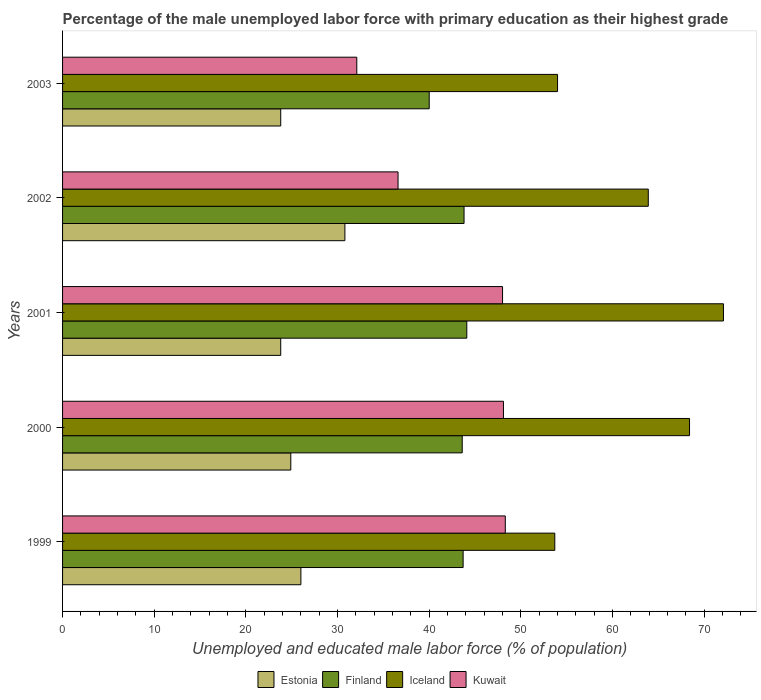How many groups of bars are there?
Ensure brevity in your answer.  5. Are the number of bars per tick equal to the number of legend labels?
Your response must be concise. Yes. Are the number of bars on each tick of the Y-axis equal?
Offer a terse response. Yes. How many bars are there on the 5th tick from the top?
Keep it short and to the point. 4. How many bars are there on the 4th tick from the bottom?
Your answer should be very brief. 4. In how many cases, is the number of bars for a given year not equal to the number of legend labels?
Offer a very short reply. 0. What is the percentage of the unemployed male labor force with primary education in Kuwait in 2000?
Your response must be concise. 48.1. Across all years, what is the maximum percentage of the unemployed male labor force with primary education in Kuwait?
Provide a short and direct response. 48.3. Across all years, what is the minimum percentage of the unemployed male labor force with primary education in Estonia?
Your answer should be very brief. 23.8. In which year was the percentage of the unemployed male labor force with primary education in Estonia maximum?
Give a very brief answer. 2002. What is the total percentage of the unemployed male labor force with primary education in Iceland in the graph?
Your answer should be very brief. 312.1. What is the difference between the percentage of the unemployed male labor force with primary education in Iceland in 1999 and that in 2002?
Provide a succinct answer. -10.2. What is the difference between the percentage of the unemployed male labor force with primary education in Iceland in 2000 and the percentage of the unemployed male labor force with primary education in Estonia in 1999?
Give a very brief answer. 42.4. What is the average percentage of the unemployed male labor force with primary education in Kuwait per year?
Ensure brevity in your answer.  42.62. In the year 2001, what is the difference between the percentage of the unemployed male labor force with primary education in Iceland and percentage of the unemployed male labor force with primary education in Kuwait?
Keep it short and to the point. 24.1. What is the ratio of the percentage of the unemployed male labor force with primary education in Iceland in 1999 to that in 2001?
Ensure brevity in your answer.  0.74. Is the difference between the percentage of the unemployed male labor force with primary education in Iceland in 1999 and 2001 greater than the difference between the percentage of the unemployed male labor force with primary education in Kuwait in 1999 and 2001?
Provide a short and direct response. No. What is the difference between the highest and the second highest percentage of the unemployed male labor force with primary education in Iceland?
Your response must be concise. 3.7. What is the difference between the highest and the lowest percentage of the unemployed male labor force with primary education in Iceland?
Offer a very short reply. 18.4. In how many years, is the percentage of the unemployed male labor force with primary education in Kuwait greater than the average percentage of the unemployed male labor force with primary education in Kuwait taken over all years?
Make the answer very short. 3. Is it the case that in every year, the sum of the percentage of the unemployed male labor force with primary education in Finland and percentage of the unemployed male labor force with primary education in Kuwait is greater than the sum of percentage of the unemployed male labor force with primary education in Estonia and percentage of the unemployed male labor force with primary education in Iceland?
Your response must be concise. No. What does the 1st bar from the top in 2000 represents?
Make the answer very short. Kuwait. What does the 4th bar from the bottom in 1999 represents?
Keep it short and to the point. Kuwait. How many bars are there?
Give a very brief answer. 20. Are all the bars in the graph horizontal?
Make the answer very short. Yes. What is the difference between two consecutive major ticks on the X-axis?
Offer a very short reply. 10. Are the values on the major ticks of X-axis written in scientific E-notation?
Your answer should be very brief. No. Does the graph contain grids?
Your answer should be compact. No. What is the title of the graph?
Ensure brevity in your answer.  Percentage of the male unemployed labor force with primary education as their highest grade. Does "Iraq" appear as one of the legend labels in the graph?
Offer a terse response. No. What is the label or title of the X-axis?
Your response must be concise. Unemployed and educated male labor force (% of population). What is the Unemployed and educated male labor force (% of population) of Estonia in 1999?
Offer a very short reply. 26. What is the Unemployed and educated male labor force (% of population) of Finland in 1999?
Provide a succinct answer. 43.7. What is the Unemployed and educated male labor force (% of population) in Iceland in 1999?
Your answer should be compact. 53.7. What is the Unemployed and educated male labor force (% of population) of Kuwait in 1999?
Provide a short and direct response. 48.3. What is the Unemployed and educated male labor force (% of population) of Estonia in 2000?
Make the answer very short. 24.9. What is the Unemployed and educated male labor force (% of population) in Finland in 2000?
Give a very brief answer. 43.6. What is the Unemployed and educated male labor force (% of population) of Iceland in 2000?
Your answer should be very brief. 68.4. What is the Unemployed and educated male labor force (% of population) of Kuwait in 2000?
Your answer should be compact. 48.1. What is the Unemployed and educated male labor force (% of population) of Estonia in 2001?
Provide a short and direct response. 23.8. What is the Unemployed and educated male labor force (% of population) in Finland in 2001?
Offer a very short reply. 44.1. What is the Unemployed and educated male labor force (% of population) in Iceland in 2001?
Offer a terse response. 72.1. What is the Unemployed and educated male labor force (% of population) in Estonia in 2002?
Your response must be concise. 30.8. What is the Unemployed and educated male labor force (% of population) of Finland in 2002?
Offer a very short reply. 43.8. What is the Unemployed and educated male labor force (% of population) in Iceland in 2002?
Your answer should be compact. 63.9. What is the Unemployed and educated male labor force (% of population) in Kuwait in 2002?
Your answer should be very brief. 36.6. What is the Unemployed and educated male labor force (% of population) in Estonia in 2003?
Offer a very short reply. 23.8. What is the Unemployed and educated male labor force (% of population) of Finland in 2003?
Your answer should be compact. 40. What is the Unemployed and educated male labor force (% of population) of Kuwait in 2003?
Your response must be concise. 32.1. Across all years, what is the maximum Unemployed and educated male labor force (% of population) in Estonia?
Your response must be concise. 30.8. Across all years, what is the maximum Unemployed and educated male labor force (% of population) of Finland?
Ensure brevity in your answer.  44.1. Across all years, what is the maximum Unemployed and educated male labor force (% of population) in Iceland?
Your answer should be very brief. 72.1. Across all years, what is the maximum Unemployed and educated male labor force (% of population) of Kuwait?
Offer a terse response. 48.3. Across all years, what is the minimum Unemployed and educated male labor force (% of population) of Estonia?
Ensure brevity in your answer.  23.8. Across all years, what is the minimum Unemployed and educated male labor force (% of population) of Finland?
Give a very brief answer. 40. Across all years, what is the minimum Unemployed and educated male labor force (% of population) of Iceland?
Your answer should be compact. 53.7. Across all years, what is the minimum Unemployed and educated male labor force (% of population) in Kuwait?
Ensure brevity in your answer.  32.1. What is the total Unemployed and educated male labor force (% of population) of Estonia in the graph?
Provide a succinct answer. 129.3. What is the total Unemployed and educated male labor force (% of population) in Finland in the graph?
Make the answer very short. 215.2. What is the total Unemployed and educated male labor force (% of population) in Iceland in the graph?
Your answer should be very brief. 312.1. What is the total Unemployed and educated male labor force (% of population) of Kuwait in the graph?
Provide a short and direct response. 213.1. What is the difference between the Unemployed and educated male labor force (% of population) in Estonia in 1999 and that in 2000?
Keep it short and to the point. 1.1. What is the difference between the Unemployed and educated male labor force (% of population) of Finland in 1999 and that in 2000?
Ensure brevity in your answer.  0.1. What is the difference between the Unemployed and educated male labor force (% of population) in Iceland in 1999 and that in 2000?
Give a very brief answer. -14.7. What is the difference between the Unemployed and educated male labor force (% of population) in Estonia in 1999 and that in 2001?
Make the answer very short. 2.2. What is the difference between the Unemployed and educated male labor force (% of population) of Finland in 1999 and that in 2001?
Make the answer very short. -0.4. What is the difference between the Unemployed and educated male labor force (% of population) in Iceland in 1999 and that in 2001?
Offer a very short reply. -18.4. What is the difference between the Unemployed and educated male labor force (% of population) of Estonia in 1999 and that in 2002?
Your answer should be very brief. -4.8. What is the difference between the Unemployed and educated male labor force (% of population) of Finland in 1999 and that in 2002?
Offer a very short reply. -0.1. What is the difference between the Unemployed and educated male labor force (% of population) in Iceland in 1999 and that in 2002?
Provide a short and direct response. -10.2. What is the difference between the Unemployed and educated male labor force (% of population) in Estonia in 1999 and that in 2003?
Provide a short and direct response. 2.2. What is the difference between the Unemployed and educated male labor force (% of population) in Estonia in 2000 and that in 2001?
Your answer should be compact. 1.1. What is the difference between the Unemployed and educated male labor force (% of population) in Iceland in 2000 and that in 2001?
Ensure brevity in your answer.  -3.7. What is the difference between the Unemployed and educated male labor force (% of population) of Kuwait in 2000 and that in 2001?
Keep it short and to the point. 0.1. What is the difference between the Unemployed and educated male labor force (% of population) of Finland in 2000 and that in 2002?
Provide a short and direct response. -0.2. What is the difference between the Unemployed and educated male labor force (% of population) in Iceland in 2000 and that in 2002?
Offer a terse response. 4.5. What is the difference between the Unemployed and educated male labor force (% of population) of Kuwait in 2000 and that in 2002?
Offer a very short reply. 11.5. What is the difference between the Unemployed and educated male labor force (% of population) of Estonia in 2000 and that in 2003?
Provide a succinct answer. 1.1. What is the difference between the Unemployed and educated male labor force (% of population) in Kuwait in 2000 and that in 2003?
Give a very brief answer. 16. What is the difference between the Unemployed and educated male labor force (% of population) in Finland in 2001 and that in 2002?
Keep it short and to the point. 0.3. What is the difference between the Unemployed and educated male labor force (% of population) of Kuwait in 2001 and that in 2002?
Keep it short and to the point. 11.4. What is the difference between the Unemployed and educated male labor force (% of population) of Estonia in 2001 and that in 2003?
Keep it short and to the point. 0. What is the difference between the Unemployed and educated male labor force (% of population) in Finland in 2001 and that in 2003?
Make the answer very short. 4.1. What is the difference between the Unemployed and educated male labor force (% of population) of Kuwait in 2002 and that in 2003?
Your answer should be compact. 4.5. What is the difference between the Unemployed and educated male labor force (% of population) of Estonia in 1999 and the Unemployed and educated male labor force (% of population) of Finland in 2000?
Your response must be concise. -17.6. What is the difference between the Unemployed and educated male labor force (% of population) of Estonia in 1999 and the Unemployed and educated male labor force (% of population) of Iceland in 2000?
Make the answer very short. -42.4. What is the difference between the Unemployed and educated male labor force (% of population) of Estonia in 1999 and the Unemployed and educated male labor force (% of population) of Kuwait in 2000?
Make the answer very short. -22.1. What is the difference between the Unemployed and educated male labor force (% of population) in Finland in 1999 and the Unemployed and educated male labor force (% of population) in Iceland in 2000?
Provide a succinct answer. -24.7. What is the difference between the Unemployed and educated male labor force (% of population) in Finland in 1999 and the Unemployed and educated male labor force (% of population) in Kuwait in 2000?
Give a very brief answer. -4.4. What is the difference between the Unemployed and educated male labor force (% of population) of Iceland in 1999 and the Unemployed and educated male labor force (% of population) of Kuwait in 2000?
Your answer should be very brief. 5.6. What is the difference between the Unemployed and educated male labor force (% of population) of Estonia in 1999 and the Unemployed and educated male labor force (% of population) of Finland in 2001?
Provide a succinct answer. -18.1. What is the difference between the Unemployed and educated male labor force (% of population) in Estonia in 1999 and the Unemployed and educated male labor force (% of population) in Iceland in 2001?
Keep it short and to the point. -46.1. What is the difference between the Unemployed and educated male labor force (% of population) of Finland in 1999 and the Unemployed and educated male labor force (% of population) of Iceland in 2001?
Your response must be concise. -28.4. What is the difference between the Unemployed and educated male labor force (% of population) of Estonia in 1999 and the Unemployed and educated male labor force (% of population) of Finland in 2002?
Your response must be concise. -17.8. What is the difference between the Unemployed and educated male labor force (% of population) of Estonia in 1999 and the Unemployed and educated male labor force (% of population) of Iceland in 2002?
Your response must be concise. -37.9. What is the difference between the Unemployed and educated male labor force (% of population) in Estonia in 1999 and the Unemployed and educated male labor force (% of population) in Kuwait in 2002?
Provide a short and direct response. -10.6. What is the difference between the Unemployed and educated male labor force (% of population) of Finland in 1999 and the Unemployed and educated male labor force (% of population) of Iceland in 2002?
Make the answer very short. -20.2. What is the difference between the Unemployed and educated male labor force (% of population) in Iceland in 1999 and the Unemployed and educated male labor force (% of population) in Kuwait in 2002?
Your response must be concise. 17.1. What is the difference between the Unemployed and educated male labor force (% of population) in Estonia in 1999 and the Unemployed and educated male labor force (% of population) in Iceland in 2003?
Your answer should be very brief. -28. What is the difference between the Unemployed and educated male labor force (% of population) of Estonia in 1999 and the Unemployed and educated male labor force (% of population) of Kuwait in 2003?
Make the answer very short. -6.1. What is the difference between the Unemployed and educated male labor force (% of population) in Finland in 1999 and the Unemployed and educated male labor force (% of population) in Kuwait in 2003?
Your answer should be compact. 11.6. What is the difference between the Unemployed and educated male labor force (% of population) of Iceland in 1999 and the Unemployed and educated male labor force (% of population) of Kuwait in 2003?
Your response must be concise. 21.6. What is the difference between the Unemployed and educated male labor force (% of population) in Estonia in 2000 and the Unemployed and educated male labor force (% of population) in Finland in 2001?
Provide a succinct answer. -19.2. What is the difference between the Unemployed and educated male labor force (% of population) in Estonia in 2000 and the Unemployed and educated male labor force (% of population) in Iceland in 2001?
Ensure brevity in your answer.  -47.2. What is the difference between the Unemployed and educated male labor force (% of population) of Estonia in 2000 and the Unemployed and educated male labor force (% of population) of Kuwait in 2001?
Your answer should be very brief. -23.1. What is the difference between the Unemployed and educated male labor force (% of population) in Finland in 2000 and the Unemployed and educated male labor force (% of population) in Iceland in 2001?
Provide a succinct answer. -28.5. What is the difference between the Unemployed and educated male labor force (% of population) of Iceland in 2000 and the Unemployed and educated male labor force (% of population) of Kuwait in 2001?
Your response must be concise. 20.4. What is the difference between the Unemployed and educated male labor force (% of population) in Estonia in 2000 and the Unemployed and educated male labor force (% of population) in Finland in 2002?
Provide a short and direct response. -18.9. What is the difference between the Unemployed and educated male labor force (% of population) of Estonia in 2000 and the Unemployed and educated male labor force (% of population) of Iceland in 2002?
Your answer should be compact. -39. What is the difference between the Unemployed and educated male labor force (% of population) of Finland in 2000 and the Unemployed and educated male labor force (% of population) of Iceland in 2002?
Your response must be concise. -20.3. What is the difference between the Unemployed and educated male labor force (% of population) in Finland in 2000 and the Unemployed and educated male labor force (% of population) in Kuwait in 2002?
Your answer should be compact. 7. What is the difference between the Unemployed and educated male labor force (% of population) of Iceland in 2000 and the Unemployed and educated male labor force (% of population) of Kuwait in 2002?
Your response must be concise. 31.8. What is the difference between the Unemployed and educated male labor force (% of population) of Estonia in 2000 and the Unemployed and educated male labor force (% of population) of Finland in 2003?
Give a very brief answer. -15.1. What is the difference between the Unemployed and educated male labor force (% of population) in Estonia in 2000 and the Unemployed and educated male labor force (% of population) in Iceland in 2003?
Ensure brevity in your answer.  -29.1. What is the difference between the Unemployed and educated male labor force (% of population) of Finland in 2000 and the Unemployed and educated male labor force (% of population) of Kuwait in 2003?
Your answer should be very brief. 11.5. What is the difference between the Unemployed and educated male labor force (% of population) of Iceland in 2000 and the Unemployed and educated male labor force (% of population) of Kuwait in 2003?
Keep it short and to the point. 36.3. What is the difference between the Unemployed and educated male labor force (% of population) in Estonia in 2001 and the Unemployed and educated male labor force (% of population) in Iceland in 2002?
Your answer should be compact. -40.1. What is the difference between the Unemployed and educated male labor force (% of population) in Estonia in 2001 and the Unemployed and educated male labor force (% of population) in Kuwait in 2002?
Your response must be concise. -12.8. What is the difference between the Unemployed and educated male labor force (% of population) of Finland in 2001 and the Unemployed and educated male labor force (% of population) of Iceland in 2002?
Offer a very short reply. -19.8. What is the difference between the Unemployed and educated male labor force (% of population) in Iceland in 2001 and the Unemployed and educated male labor force (% of population) in Kuwait in 2002?
Ensure brevity in your answer.  35.5. What is the difference between the Unemployed and educated male labor force (% of population) of Estonia in 2001 and the Unemployed and educated male labor force (% of population) of Finland in 2003?
Your response must be concise. -16.2. What is the difference between the Unemployed and educated male labor force (% of population) in Estonia in 2001 and the Unemployed and educated male labor force (% of population) in Iceland in 2003?
Offer a terse response. -30.2. What is the difference between the Unemployed and educated male labor force (% of population) of Finland in 2001 and the Unemployed and educated male labor force (% of population) of Iceland in 2003?
Your response must be concise. -9.9. What is the difference between the Unemployed and educated male labor force (% of population) of Iceland in 2001 and the Unemployed and educated male labor force (% of population) of Kuwait in 2003?
Provide a succinct answer. 40. What is the difference between the Unemployed and educated male labor force (% of population) in Estonia in 2002 and the Unemployed and educated male labor force (% of population) in Finland in 2003?
Give a very brief answer. -9.2. What is the difference between the Unemployed and educated male labor force (% of population) of Estonia in 2002 and the Unemployed and educated male labor force (% of population) of Iceland in 2003?
Provide a succinct answer. -23.2. What is the difference between the Unemployed and educated male labor force (% of population) in Iceland in 2002 and the Unemployed and educated male labor force (% of population) in Kuwait in 2003?
Ensure brevity in your answer.  31.8. What is the average Unemployed and educated male labor force (% of population) of Estonia per year?
Offer a terse response. 25.86. What is the average Unemployed and educated male labor force (% of population) in Finland per year?
Provide a succinct answer. 43.04. What is the average Unemployed and educated male labor force (% of population) of Iceland per year?
Ensure brevity in your answer.  62.42. What is the average Unemployed and educated male labor force (% of population) in Kuwait per year?
Provide a short and direct response. 42.62. In the year 1999, what is the difference between the Unemployed and educated male labor force (% of population) of Estonia and Unemployed and educated male labor force (% of population) of Finland?
Give a very brief answer. -17.7. In the year 1999, what is the difference between the Unemployed and educated male labor force (% of population) in Estonia and Unemployed and educated male labor force (% of population) in Iceland?
Offer a terse response. -27.7. In the year 1999, what is the difference between the Unemployed and educated male labor force (% of population) in Estonia and Unemployed and educated male labor force (% of population) in Kuwait?
Your response must be concise. -22.3. In the year 1999, what is the difference between the Unemployed and educated male labor force (% of population) of Finland and Unemployed and educated male labor force (% of population) of Iceland?
Your response must be concise. -10. In the year 1999, what is the difference between the Unemployed and educated male labor force (% of population) in Finland and Unemployed and educated male labor force (% of population) in Kuwait?
Keep it short and to the point. -4.6. In the year 1999, what is the difference between the Unemployed and educated male labor force (% of population) of Iceland and Unemployed and educated male labor force (% of population) of Kuwait?
Your response must be concise. 5.4. In the year 2000, what is the difference between the Unemployed and educated male labor force (% of population) in Estonia and Unemployed and educated male labor force (% of population) in Finland?
Give a very brief answer. -18.7. In the year 2000, what is the difference between the Unemployed and educated male labor force (% of population) in Estonia and Unemployed and educated male labor force (% of population) in Iceland?
Ensure brevity in your answer.  -43.5. In the year 2000, what is the difference between the Unemployed and educated male labor force (% of population) in Estonia and Unemployed and educated male labor force (% of population) in Kuwait?
Give a very brief answer. -23.2. In the year 2000, what is the difference between the Unemployed and educated male labor force (% of population) of Finland and Unemployed and educated male labor force (% of population) of Iceland?
Offer a very short reply. -24.8. In the year 2000, what is the difference between the Unemployed and educated male labor force (% of population) in Iceland and Unemployed and educated male labor force (% of population) in Kuwait?
Your response must be concise. 20.3. In the year 2001, what is the difference between the Unemployed and educated male labor force (% of population) in Estonia and Unemployed and educated male labor force (% of population) in Finland?
Offer a very short reply. -20.3. In the year 2001, what is the difference between the Unemployed and educated male labor force (% of population) of Estonia and Unemployed and educated male labor force (% of population) of Iceland?
Provide a short and direct response. -48.3. In the year 2001, what is the difference between the Unemployed and educated male labor force (% of population) of Estonia and Unemployed and educated male labor force (% of population) of Kuwait?
Your answer should be compact. -24.2. In the year 2001, what is the difference between the Unemployed and educated male labor force (% of population) of Iceland and Unemployed and educated male labor force (% of population) of Kuwait?
Your answer should be very brief. 24.1. In the year 2002, what is the difference between the Unemployed and educated male labor force (% of population) of Estonia and Unemployed and educated male labor force (% of population) of Iceland?
Keep it short and to the point. -33.1. In the year 2002, what is the difference between the Unemployed and educated male labor force (% of population) in Finland and Unemployed and educated male labor force (% of population) in Iceland?
Make the answer very short. -20.1. In the year 2002, what is the difference between the Unemployed and educated male labor force (% of population) in Finland and Unemployed and educated male labor force (% of population) in Kuwait?
Your answer should be compact. 7.2. In the year 2002, what is the difference between the Unemployed and educated male labor force (% of population) in Iceland and Unemployed and educated male labor force (% of population) in Kuwait?
Your answer should be very brief. 27.3. In the year 2003, what is the difference between the Unemployed and educated male labor force (% of population) in Estonia and Unemployed and educated male labor force (% of population) in Finland?
Provide a succinct answer. -16.2. In the year 2003, what is the difference between the Unemployed and educated male labor force (% of population) in Estonia and Unemployed and educated male labor force (% of population) in Iceland?
Your answer should be compact. -30.2. In the year 2003, what is the difference between the Unemployed and educated male labor force (% of population) in Finland and Unemployed and educated male labor force (% of population) in Kuwait?
Keep it short and to the point. 7.9. In the year 2003, what is the difference between the Unemployed and educated male labor force (% of population) in Iceland and Unemployed and educated male labor force (% of population) in Kuwait?
Your response must be concise. 21.9. What is the ratio of the Unemployed and educated male labor force (% of population) in Estonia in 1999 to that in 2000?
Your answer should be very brief. 1.04. What is the ratio of the Unemployed and educated male labor force (% of population) in Finland in 1999 to that in 2000?
Make the answer very short. 1. What is the ratio of the Unemployed and educated male labor force (% of population) in Iceland in 1999 to that in 2000?
Your answer should be very brief. 0.79. What is the ratio of the Unemployed and educated male labor force (% of population) of Kuwait in 1999 to that in 2000?
Provide a succinct answer. 1. What is the ratio of the Unemployed and educated male labor force (% of population) of Estonia in 1999 to that in 2001?
Your response must be concise. 1.09. What is the ratio of the Unemployed and educated male labor force (% of population) in Finland in 1999 to that in 2001?
Provide a short and direct response. 0.99. What is the ratio of the Unemployed and educated male labor force (% of population) of Iceland in 1999 to that in 2001?
Offer a terse response. 0.74. What is the ratio of the Unemployed and educated male labor force (% of population) in Estonia in 1999 to that in 2002?
Provide a short and direct response. 0.84. What is the ratio of the Unemployed and educated male labor force (% of population) in Iceland in 1999 to that in 2002?
Your answer should be very brief. 0.84. What is the ratio of the Unemployed and educated male labor force (% of population) in Kuwait in 1999 to that in 2002?
Offer a very short reply. 1.32. What is the ratio of the Unemployed and educated male labor force (% of population) of Estonia in 1999 to that in 2003?
Provide a succinct answer. 1.09. What is the ratio of the Unemployed and educated male labor force (% of population) in Finland in 1999 to that in 2003?
Your response must be concise. 1.09. What is the ratio of the Unemployed and educated male labor force (% of population) of Iceland in 1999 to that in 2003?
Keep it short and to the point. 0.99. What is the ratio of the Unemployed and educated male labor force (% of population) of Kuwait in 1999 to that in 2003?
Your answer should be compact. 1.5. What is the ratio of the Unemployed and educated male labor force (% of population) of Estonia in 2000 to that in 2001?
Your answer should be compact. 1.05. What is the ratio of the Unemployed and educated male labor force (% of population) in Finland in 2000 to that in 2001?
Offer a very short reply. 0.99. What is the ratio of the Unemployed and educated male labor force (% of population) of Iceland in 2000 to that in 2001?
Your answer should be very brief. 0.95. What is the ratio of the Unemployed and educated male labor force (% of population) of Kuwait in 2000 to that in 2001?
Your response must be concise. 1. What is the ratio of the Unemployed and educated male labor force (% of population) in Estonia in 2000 to that in 2002?
Your response must be concise. 0.81. What is the ratio of the Unemployed and educated male labor force (% of population) of Iceland in 2000 to that in 2002?
Offer a terse response. 1.07. What is the ratio of the Unemployed and educated male labor force (% of population) in Kuwait in 2000 to that in 2002?
Offer a terse response. 1.31. What is the ratio of the Unemployed and educated male labor force (% of population) in Estonia in 2000 to that in 2003?
Give a very brief answer. 1.05. What is the ratio of the Unemployed and educated male labor force (% of population) in Finland in 2000 to that in 2003?
Keep it short and to the point. 1.09. What is the ratio of the Unemployed and educated male labor force (% of population) in Iceland in 2000 to that in 2003?
Your answer should be compact. 1.27. What is the ratio of the Unemployed and educated male labor force (% of population) of Kuwait in 2000 to that in 2003?
Ensure brevity in your answer.  1.5. What is the ratio of the Unemployed and educated male labor force (% of population) of Estonia in 2001 to that in 2002?
Your answer should be very brief. 0.77. What is the ratio of the Unemployed and educated male labor force (% of population) in Finland in 2001 to that in 2002?
Ensure brevity in your answer.  1.01. What is the ratio of the Unemployed and educated male labor force (% of population) in Iceland in 2001 to that in 2002?
Provide a short and direct response. 1.13. What is the ratio of the Unemployed and educated male labor force (% of population) of Kuwait in 2001 to that in 2002?
Give a very brief answer. 1.31. What is the ratio of the Unemployed and educated male labor force (% of population) of Estonia in 2001 to that in 2003?
Your answer should be compact. 1. What is the ratio of the Unemployed and educated male labor force (% of population) in Finland in 2001 to that in 2003?
Your response must be concise. 1.1. What is the ratio of the Unemployed and educated male labor force (% of population) of Iceland in 2001 to that in 2003?
Give a very brief answer. 1.34. What is the ratio of the Unemployed and educated male labor force (% of population) in Kuwait in 2001 to that in 2003?
Give a very brief answer. 1.5. What is the ratio of the Unemployed and educated male labor force (% of population) in Estonia in 2002 to that in 2003?
Provide a short and direct response. 1.29. What is the ratio of the Unemployed and educated male labor force (% of population) in Finland in 2002 to that in 2003?
Offer a terse response. 1.09. What is the ratio of the Unemployed and educated male labor force (% of population) in Iceland in 2002 to that in 2003?
Offer a terse response. 1.18. What is the ratio of the Unemployed and educated male labor force (% of population) of Kuwait in 2002 to that in 2003?
Provide a succinct answer. 1.14. What is the difference between the highest and the second highest Unemployed and educated male labor force (% of population) in Finland?
Offer a terse response. 0.3. What is the difference between the highest and the second highest Unemployed and educated male labor force (% of population) in Kuwait?
Provide a short and direct response. 0.2. What is the difference between the highest and the lowest Unemployed and educated male labor force (% of population) in Iceland?
Make the answer very short. 18.4. 